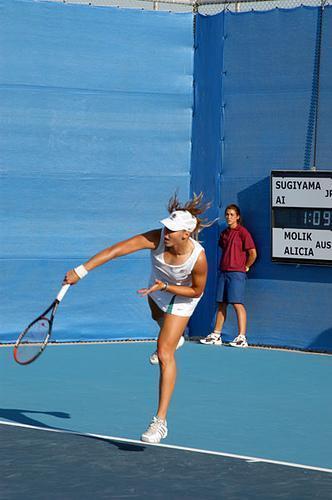How many people are there?
Give a very brief answer. 2. 